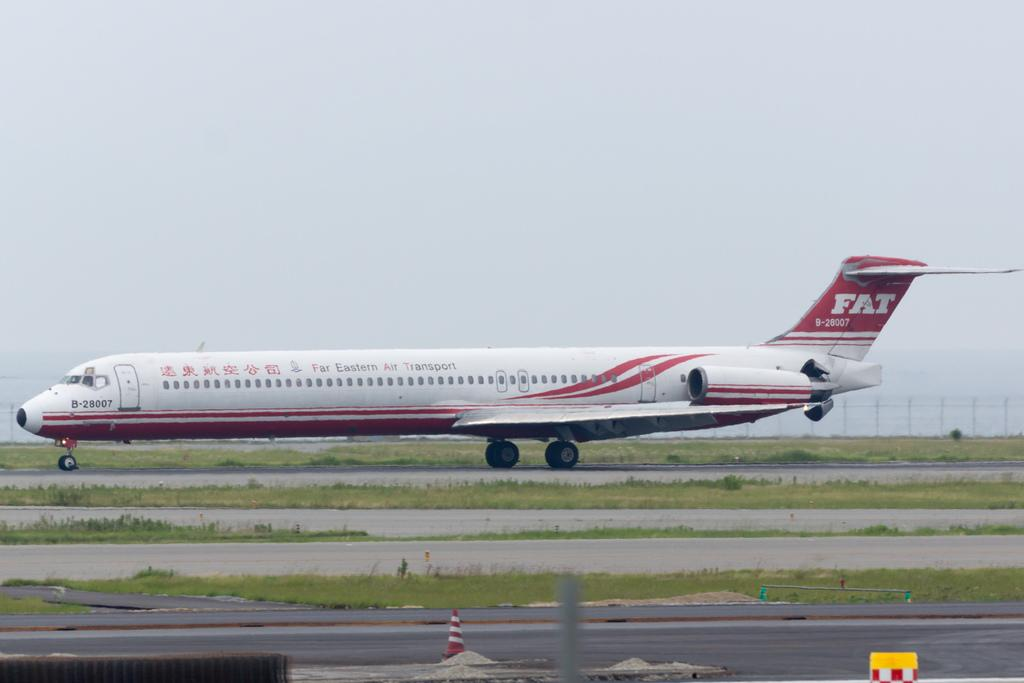<image>
Relay a brief, clear account of the picture shown. A Far Eastern Transport Airplane makes its way down the tarmac 